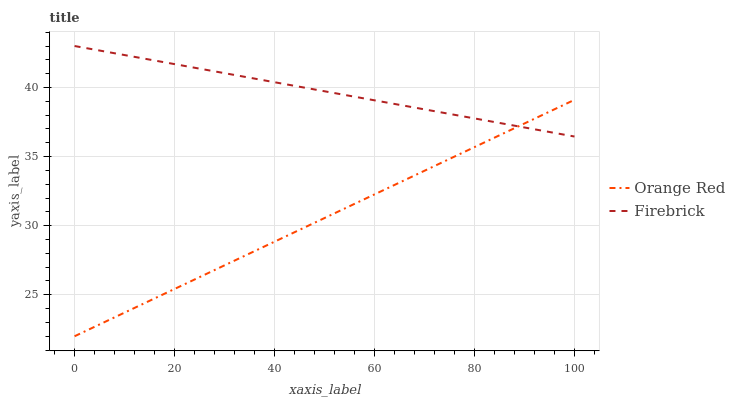Does Orange Red have the minimum area under the curve?
Answer yes or no. Yes. Does Firebrick have the maximum area under the curve?
Answer yes or no. Yes. Does Orange Red have the maximum area under the curve?
Answer yes or no. No. Is Orange Red the smoothest?
Answer yes or no. Yes. Is Firebrick the roughest?
Answer yes or no. Yes. Is Orange Red the roughest?
Answer yes or no. No. Does Orange Red have the lowest value?
Answer yes or no. Yes. Does Firebrick have the highest value?
Answer yes or no. Yes. Does Orange Red have the highest value?
Answer yes or no. No. Does Orange Red intersect Firebrick?
Answer yes or no. Yes. Is Orange Red less than Firebrick?
Answer yes or no. No. Is Orange Red greater than Firebrick?
Answer yes or no. No. 